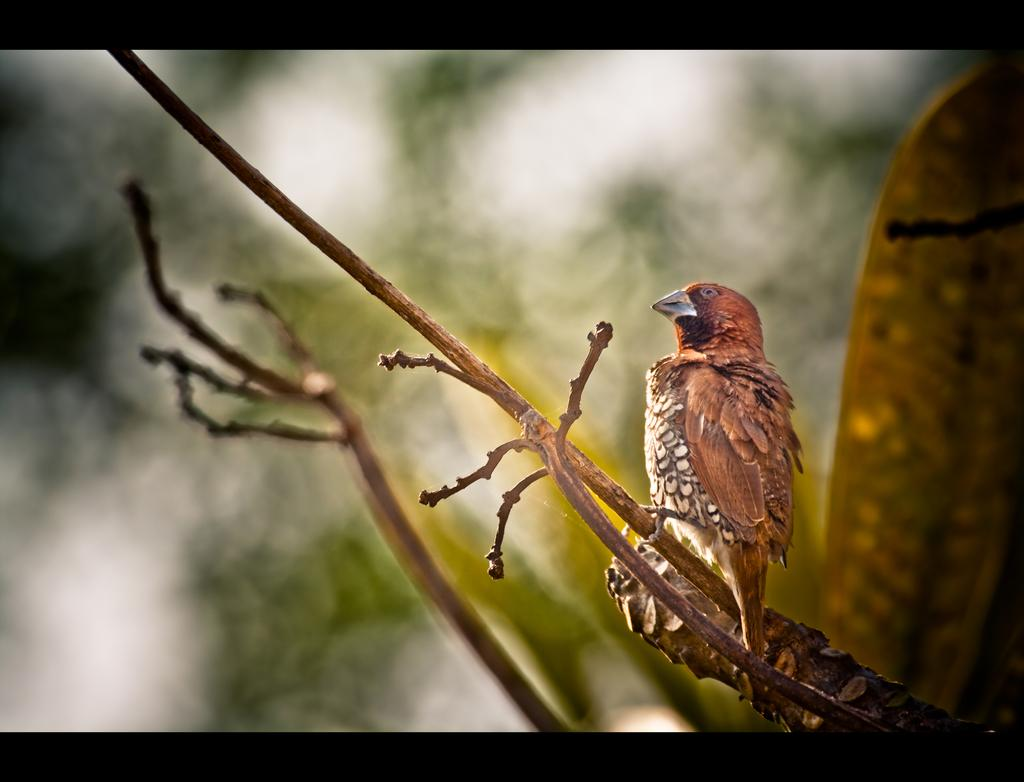What type of animal can be seen in the image? There is a bird in the image. Where is the bird located in the image? The bird is standing on a branch of a tree. On which side of the image is the branch located? The branch is on the right side of the image. How would you describe the background of the image? The background of the image is blurred. Is the bird sinking in quicksand in the image? No, there is no quicksand present in the image. The bird is standing on a branch of a tree. 